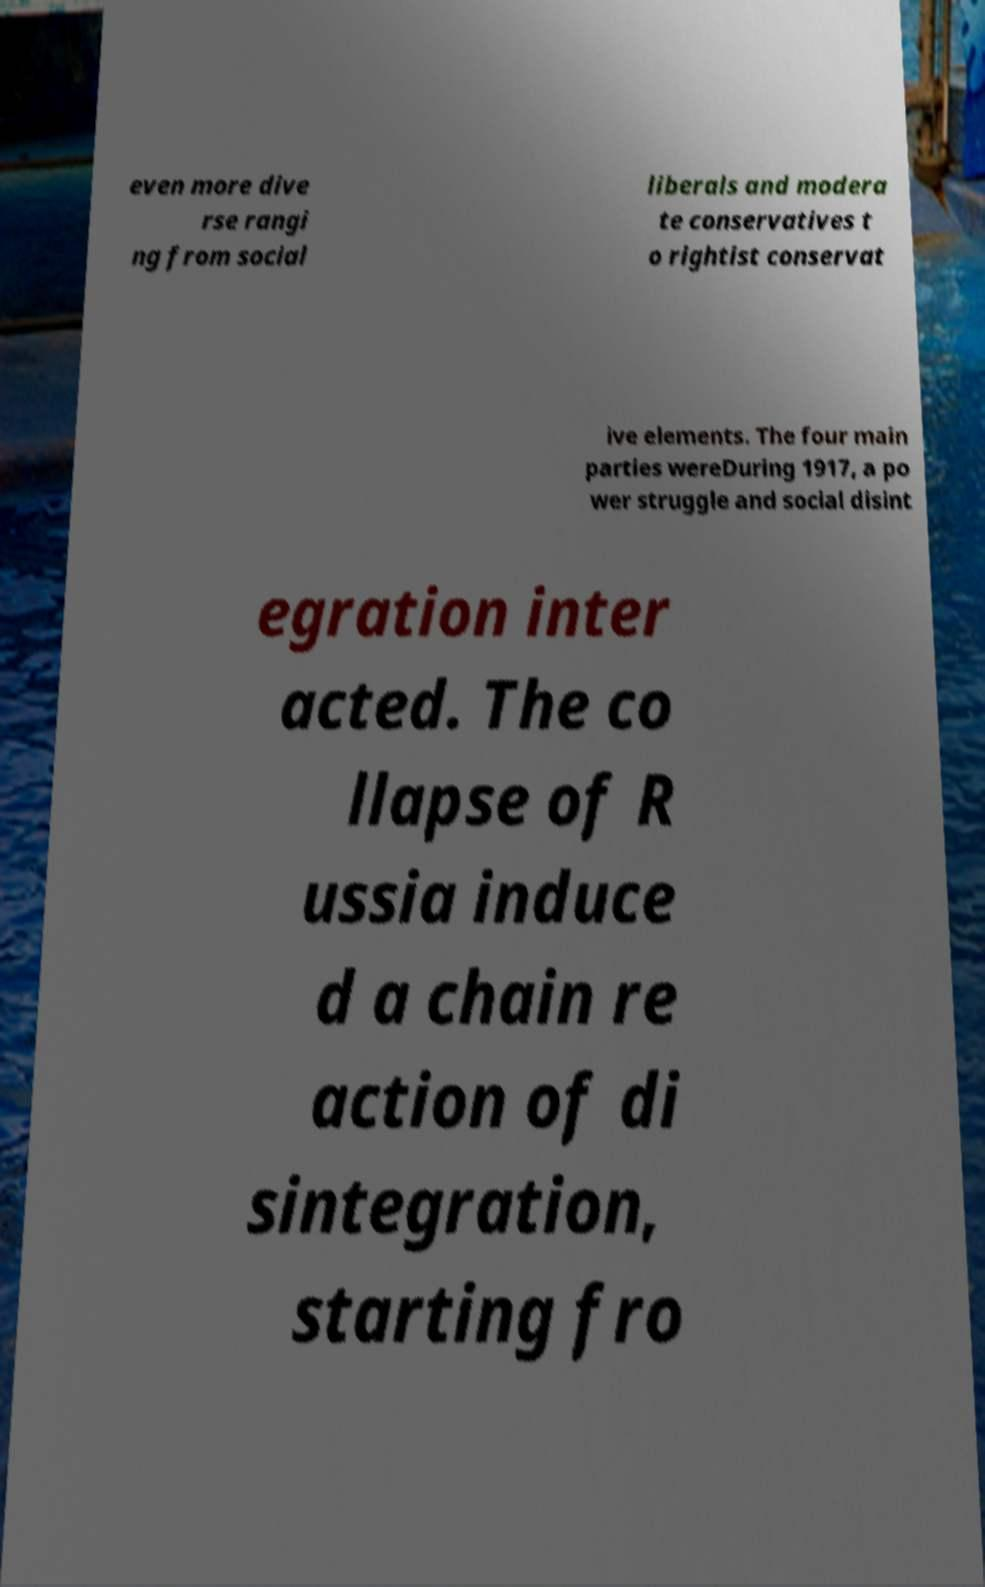I need the written content from this picture converted into text. Can you do that? even more dive rse rangi ng from social liberals and modera te conservatives t o rightist conservat ive elements. The four main parties wereDuring 1917, a po wer struggle and social disint egration inter acted. The co llapse of R ussia induce d a chain re action of di sintegration, starting fro 